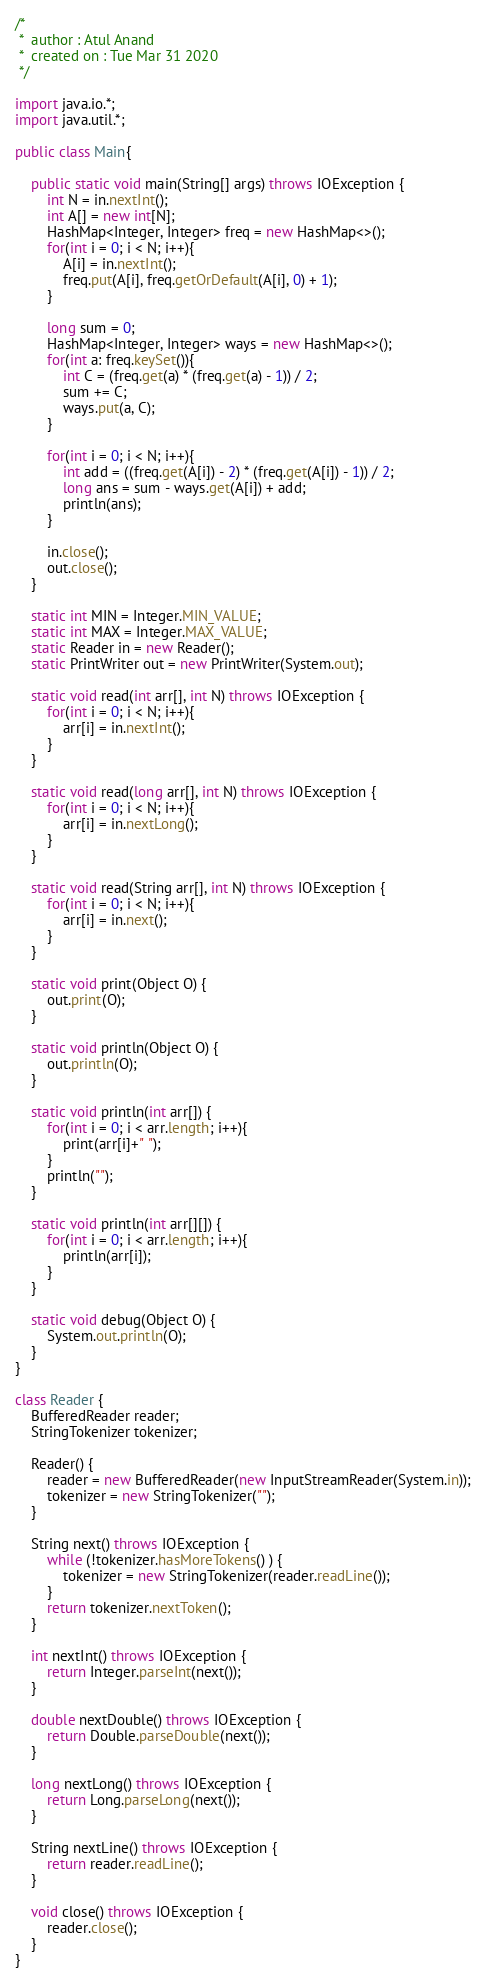<code> <loc_0><loc_0><loc_500><loc_500><_Java_>/*
 *  author : Atul Anand   
 *  created on : Tue Mar 31 2020
 */

import java.io.*;
import java.util.*;

public class Main{

    public static void main(String[] args) throws IOException {
        int N = in.nextInt();
        int A[] = new int[N];
        HashMap<Integer, Integer> freq = new HashMap<>();
        for(int i = 0; i < N; i++){
            A[i] = in.nextInt();
            freq.put(A[i], freq.getOrDefault(A[i], 0) + 1);
        }

        long sum = 0;
        HashMap<Integer, Integer> ways = new HashMap<>();
        for(int a: freq.keySet()){
            int C = (freq.get(a) * (freq.get(a) - 1)) / 2;
            sum += C;
            ways.put(a, C);
        }

        for(int i = 0; i < N; i++){
            int add = ((freq.get(A[i]) - 2) * (freq.get(A[i]) - 1)) / 2;
            long ans = sum - ways.get(A[i]) + add;
            println(ans); 
        }

        in.close();
        out.close();
    }

    static int MIN = Integer.MIN_VALUE;
    static int MAX = Integer.MAX_VALUE;
    static Reader in = new Reader();
    static PrintWriter out = new PrintWriter(System.out);

    static void read(int arr[], int N) throws IOException { 
    	for(int i = 0; i < N; i++){ 
    		arr[i] = in.nextInt(); 
    	} 
    }
    
    static void read(long arr[], int N) throws IOException { 
    	for(int i = 0; i < N; i++){ 
    		arr[i] = in.nextLong(); 
    	} 
    }
    
    static void read(String arr[], int N) throws IOException { 
    	for(int i = 0; i < N; i++){ 
    		arr[i] = in.next(); 
    	} 
    }
    
    static void print(Object O) {  
    	out.print(O); 
    }
    
    static void println(Object O) { 
    	out.println(O); 
    }
    
    static void println(int arr[]) { 
    	for(int i = 0; i < arr.length; i++){ 
    		print(arr[i]+" "); 
    	} 
    	println(""); 
    }

    static void println(int arr[][]) { 
    	for(int i = 0; i < arr.length; i++){ 
    		println(arr[i]); 
    	}
    }
    
    static void debug(Object O) { 
    	System.out.println(O); 
    }
}

class Reader {
    BufferedReader reader;
    StringTokenizer tokenizer;

    Reader() {
        reader = new BufferedReader(new InputStreamReader(System.in));
        tokenizer = new StringTokenizer("");
    }

    String next() throws IOException {
        while (!tokenizer.hasMoreTokens() ) { 
            tokenizer = new StringTokenizer(reader.readLine()); 
        }
        return tokenizer.nextToken();
    }

    int nextInt() throws IOException { 
        return Integer.parseInt(next()); 
    }
    
    double nextDouble() throws IOException { 
        return Double.parseDouble(next());
    }
    
    long nextLong() throws IOException { 
        return Long.parseLong(next()); 
    }
    
    String nextLine() throws IOException { 
        return reader.readLine(); 
    }
    
    void close() throws IOException { 
        reader.close(); 
    }
}</code> 